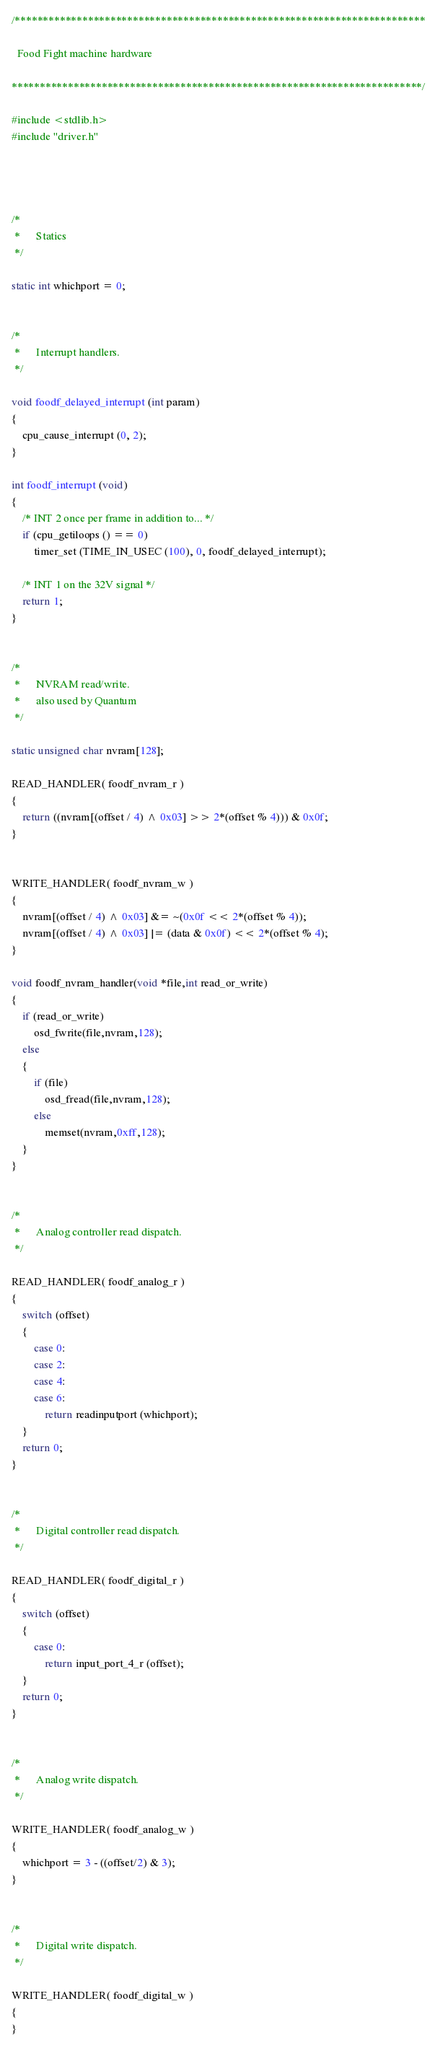<code> <loc_0><loc_0><loc_500><loc_500><_C++_>/*************************************************************************

  Food Fight machine hardware

*************************************************************************/

#include <stdlib.h>
#include "driver.h"




/*
 *		Statics
 */

static int whichport = 0;


/*
 *		Interrupt handlers.
 */

void foodf_delayed_interrupt (int param)
{
	cpu_cause_interrupt (0, 2);
}

int foodf_interrupt (void)
{
	/* INT 2 once per frame in addition to... */
	if (cpu_getiloops () == 0)
		timer_set (TIME_IN_USEC (100), 0, foodf_delayed_interrupt);

	/* INT 1 on the 32V signal */
	return 1;
}


/*
 *		NVRAM read/write.
 *      also used by Quantum
 */

static unsigned char nvram[128];

READ_HANDLER( foodf_nvram_r )
{
	return ((nvram[(offset / 4) ^ 0x03] >> 2*(offset % 4))) & 0x0f;
}


WRITE_HANDLER( foodf_nvram_w )
{
	nvram[(offset / 4) ^ 0x03] &= ~(0x0f << 2*(offset % 4));
	nvram[(offset / 4) ^ 0x03] |= (data & 0x0f) << 2*(offset % 4);
}

void foodf_nvram_handler(void *file,int read_or_write)
{
	if (read_or_write)
		osd_fwrite(file,nvram,128);
	else
	{
		if (file)
			osd_fread(file,nvram,128);
		else
			memset(nvram,0xff,128);
	}
}


/*
 *		Analog controller read dispatch.
 */

READ_HANDLER( foodf_analog_r )
{
	switch (offset)
	{
		case 0:
		case 2:
		case 4:
		case 6:
			return readinputport (whichport);
	}
	return 0;
}


/*
 *		Digital controller read dispatch.
 */

READ_HANDLER( foodf_digital_r )
{
	switch (offset)
	{
		case 0:
			return input_port_4_r (offset);
	}
	return 0;
}


/*
 *		Analog write dispatch.
 */

WRITE_HANDLER( foodf_analog_w )
{
	whichport = 3 - ((offset/2) & 3);
}


/*
 *		Digital write dispatch.
 */

WRITE_HANDLER( foodf_digital_w )
{
}
</code> 